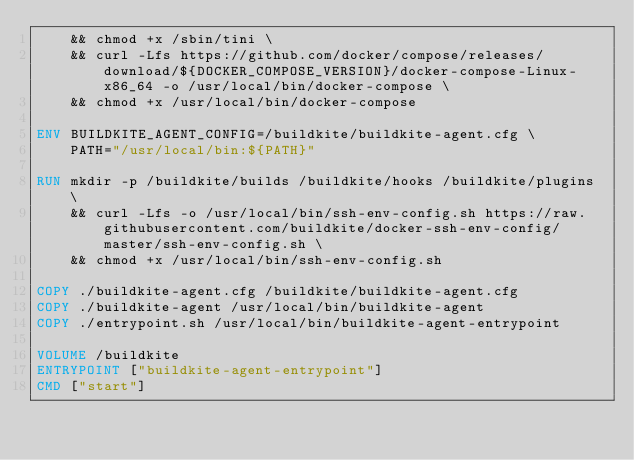Convert code to text. <code><loc_0><loc_0><loc_500><loc_500><_Dockerfile_>    && chmod +x /sbin/tini \
    && curl -Lfs https://github.com/docker/compose/releases/download/${DOCKER_COMPOSE_VERSION}/docker-compose-Linux-x86_64 -o /usr/local/bin/docker-compose \
    && chmod +x /usr/local/bin/docker-compose

ENV BUILDKITE_AGENT_CONFIG=/buildkite/buildkite-agent.cfg \
    PATH="/usr/local/bin:${PATH}"

RUN mkdir -p /buildkite/builds /buildkite/hooks /buildkite/plugins \
    && curl -Lfs -o /usr/local/bin/ssh-env-config.sh https://raw.githubusercontent.com/buildkite/docker-ssh-env-config/master/ssh-env-config.sh \
    && chmod +x /usr/local/bin/ssh-env-config.sh

COPY ./buildkite-agent.cfg /buildkite/buildkite-agent.cfg
COPY ./buildkite-agent /usr/local/bin/buildkite-agent
COPY ./entrypoint.sh /usr/local/bin/buildkite-agent-entrypoint

VOLUME /buildkite
ENTRYPOINT ["buildkite-agent-entrypoint"]
CMD ["start"]
</code> 